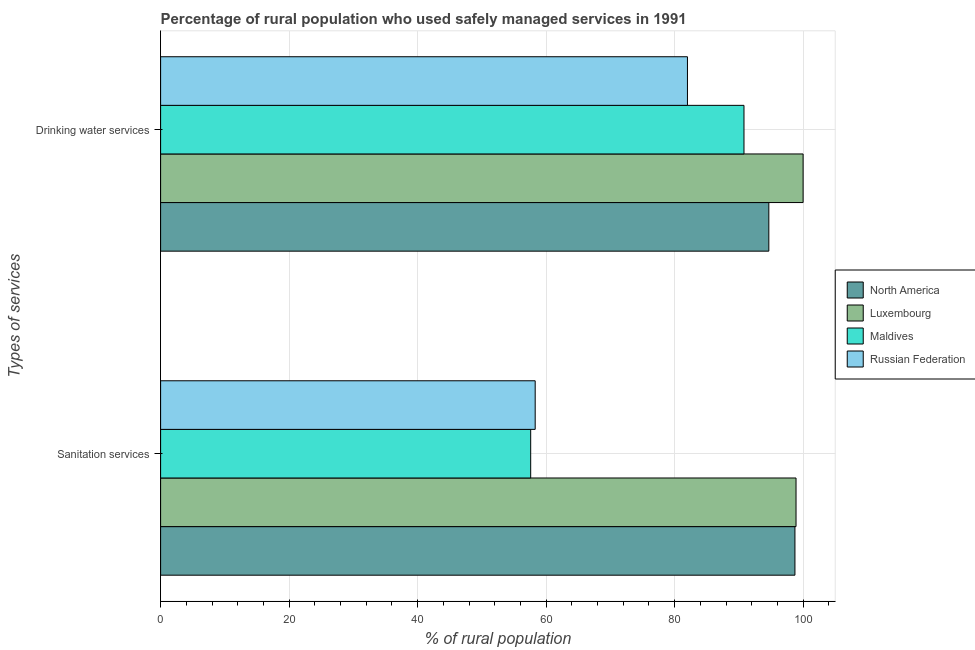How many different coloured bars are there?
Your answer should be very brief. 4. Are the number of bars per tick equal to the number of legend labels?
Your response must be concise. Yes. Are the number of bars on each tick of the Y-axis equal?
Your answer should be very brief. Yes. What is the label of the 1st group of bars from the top?
Make the answer very short. Drinking water services. What is the percentage of rural population who used sanitation services in Luxembourg?
Ensure brevity in your answer.  98.9. Across all countries, what is the maximum percentage of rural population who used drinking water services?
Make the answer very short. 100. Across all countries, what is the minimum percentage of rural population who used sanitation services?
Make the answer very short. 57.6. In which country was the percentage of rural population who used sanitation services maximum?
Your answer should be very brief. Luxembourg. In which country was the percentage of rural population who used drinking water services minimum?
Provide a succinct answer. Russian Federation. What is the total percentage of rural population who used drinking water services in the graph?
Your response must be concise. 367.46. What is the difference between the percentage of rural population who used drinking water services in Maldives and that in North America?
Offer a terse response. -3.86. What is the difference between the percentage of rural population who used sanitation services in Luxembourg and the percentage of rural population who used drinking water services in North America?
Make the answer very short. 4.24. What is the average percentage of rural population who used sanitation services per country?
Give a very brief answer. 78.38. What is the difference between the percentage of rural population who used drinking water services and percentage of rural population who used sanitation services in Luxembourg?
Your answer should be compact. 1.1. In how many countries, is the percentage of rural population who used drinking water services greater than 64 %?
Ensure brevity in your answer.  4. What is the ratio of the percentage of rural population who used sanitation services in Maldives to that in Russian Federation?
Make the answer very short. 0.99. In how many countries, is the percentage of rural population who used sanitation services greater than the average percentage of rural population who used sanitation services taken over all countries?
Ensure brevity in your answer.  2. What does the 1st bar from the top in Drinking water services represents?
Ensure brevity in your answer.  Russian Federation. What does the 1st bar from the bottom in Sanitation services represents?
Make the answer very short. North America. Are all the bars in the graph horizontal?
Ensure brevity in your answer.  Yes. What is the difference between two consecutive major ticks on the X-axis?
Give a very brief answer. 20. How many legend labels are there?
Make the answer very short. 4. What is the title of the graph?
Ensure brevity in your answer.  Percentage of rural population who used safely managed services in 1991. What is the label or title of the X-axis?
Provide a succinct answer. % of rural population. What is the label or title of the Y-axis?
Ensure brevity in your answer.  Types of services. What is the % of rural population of North America in Sanitation services?
Make the answer very short. 98.73. What is the % of rural population of Luxembourg in Sanitation services?
Your response must be concise. 98.9. What is the % of rural population of Maldives in Sanitation services?
Provide a succinct answer. 57.6. What is the % of rural population in Russian Federation in Sanitation services?
Make the answer very short. 58.3. What is the % of rural population in North America in Drinking water services?
Offer a terse response. 94.66. What is the % of rural population of Luxembourg in Drinking water services?
Ensure brevity in your answer.  100. What is the % of rural population of Maldives in Drinking water services?
Keep it short and to the point. 90.8. What is the % of rural population of Russian Federation in Drinking water services?
Provide a succinct answer. 82. Across all Types of services, what is the maximum % of rural population in North America?
Keep it short and to the point. 98.73. Across all Types of services, what is the maximum % of rural population of Maldives?
Offer a very short reply. 90.8. Across all Types of services, what is the minimum % of rural population in North America?
Your response must be concise. 94.66. Across all Types of services, what is the minimum % of rural population of Luxembourg?
Provide a succinct answer. 98.9. Across all Types of services, what is the minimum % of rural population of Maldives?
Give a very brief answer. 57.6. Across all Types of services, what is the minimum % of rural population in Russian Federation?
Ensure brevity in your answer.  58.3. What is the total % of rural population in North America in the graph?
Make the answer very short. 193.39. What is the total % of rural population in Luxembourg in the graph?
Give a very brief answer. 198.9. What is the total % of rural population in Maldives in the graph?
Your response must be concise. 148.4. What is the total % of rural population in Russian Federation in the graph?
Make the answer very short. 140.3. What is the difference between the % of rural population in North America in Sanitation services and that in Drinking water services?
Offer a terse response. 4.06. What is the difference between the % of rural population in Maldives in Sanitation services and that in Drinking water services?
Offer a terse response. -33.2. What is the difference between the % of rural population of Russian Federation in Sanitation services and that in Drinking water services?
Your answer should be compact. -23.7. What is the difference between the % of rural population in North America in Sanitation services and the % of rural population in Luxembourg in Drinking water services?
Make the answer very short. -1.27. What is the difference between the % of rural population in North America in Sanitation services and the % of rural population in Maldives in Drinking water services?
Offer a very short reply. 7.93. What is the difference between the % of rural population of North America in Sanitation services and the % of rural population of Russian Federation in Drinking water services?
Ensure brevity in your answer.  16.73. What is the difference between the % of rural population in Luxembourg in Sanitation services and the % of rural population in Russian Federation in Drinking water services?
Offer a very short reply. 16.9. What is the difference between the % of rural population of Maldives in Sanitation services and the % of rural population of Russian Federation in Drinking water services?
Your answer should be compact. -24.4. What is the average % of rural population of North America per Types of services?
Keep it short and to the point. 96.7. What is the average % of rural population in Luxembourg per Types of services?
Your answer should be compact. 99.45. What is the average % of rural population of Maldives per Types of services?
Your answer should be compact. 74.2. What is the average % of rural population of Russian Federation per Types of services?
Ensure brevity in your answer.  70.15. What is the difference between the % of rural population of North America and % of rural population of Luxembourg in Sanitation services?
Give a very brief answer. -0.17. What is the difference between the % of rural population in North America and % of rural population in Maldives in Sanitation services?
Your answer should be compact. 41.13. What is the difference between the % of rural population of North America and % of rural population of Russian Federation in Sanitation services?
Make the answer very short. 40.43. What is the difference between the % of rural population in Luxembourg and % of rural population in Maldives in Sanitation services?
Ensure brevity in your answer.  41.3. What is the difference between the % of rural population in Luxembourg and % of rural population in Russian Federation in Sanitation services?
Provide a short and direct response. 40.6. What is the difference between the % of rural population of North America and % of rural population of Luxembourg in Drinking water services?
Keep it short and to the point. -5.34. What is the difference between the % of rural population of North America and % of rural population of Maldives in Drinking water services?
Your answer should be very brief. 3.86. What is the difference between the % of rural population of North America and % of rural population of Russian Federation in Drinking water services?
Offer a very short reply. 12.66. What is the difference between the % of rural population of Luxembourg and % of rural population of Russian Federation in Drinking water services?
Your response must be concise. 18. What is the difference between the % of rural population in Maldives and % of rural population in Russian Federation in Drinking water services?
Offer a very short reply. 8.8. What is the ratio of the % of rural population of North America in Sanitation services to that in Drinking water services?
Offer a terse response. 1.04. What is the ratio of the % of rural population in Maldives in Sanitation services to that in Drinking water services?
Provide a short and direct response. 0.63. What is the ratio of the % of rural population in Russian Federation in Sanitation services to that in Drinking water services?
Your answer should be compact. 0.71. What is the difference between the highest and the second highest % of rural population in North America?
Keep it short and to the point. 4.06. What is the difference between the highest and the second highest % of rural population in Luxembourg?
Offer a very short reply. 1.1. What is the difference between the highest and the second highest % of rural population in Maldives?
Give a very brief answer. 33.2. What is the difference between the highest and the second highest % of rural population of Russian Federation?
Provide a succinct answer. 23.7. What is the difference between the highest and the lowest % of rural population of North America?
Offer a terse response. 4.06. What is the difference between the highest and the lowest % of rural population in Maldives?
Offer a very short reply. 33.2. What is the difference between the highest and the lowest % of rural population of Russian Federation?
Your answer should be compact. 23.7. 